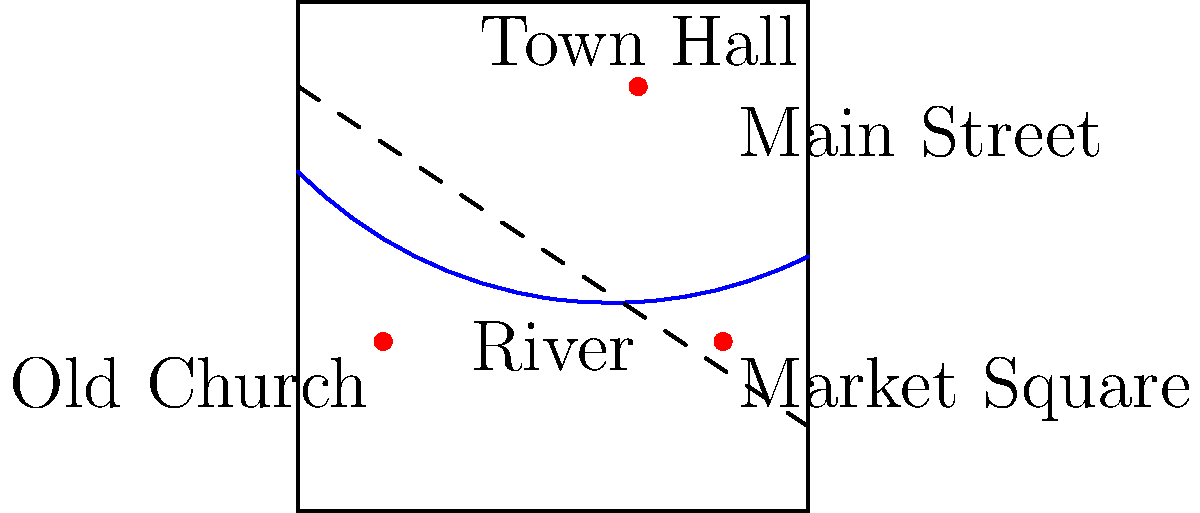Analyze the old town map provided. Which historical landmark is located closest to the intersection of the river and Main Street? To determine which historical landmark is closest to the intersection of the river and Main Street, we need to follow these steps:

1. Identify the intersection point of the river and Main Street:
   The river flows from the left side of the map to the right, curving slightly.
   Main Street is represented by the dashed line running diagonally from top-left to bottom-right.
   These two features intersect near the center of the map.

2. Locate the historical landmarks:
   a. Town Hall: positioned in the upper-right quadrant of the map
   b. Old Church: located in the lower-left quadrant
   c. Market Square: situated in the lower-right quadrant

3. Visually estimate the distances from each landmark to the intersection point:
   a. Town Hall appears to be the farthest from the intersection
   b. Old Church is closer to the intersection than Town Hall, but still relatively far
   c. Market Square is visibly the closest to the intersection point

4. Compare the estimated distances:
   Market Square is clearly the closest landmark to the intersection of the river and Main Street.
Answer: Market Square 